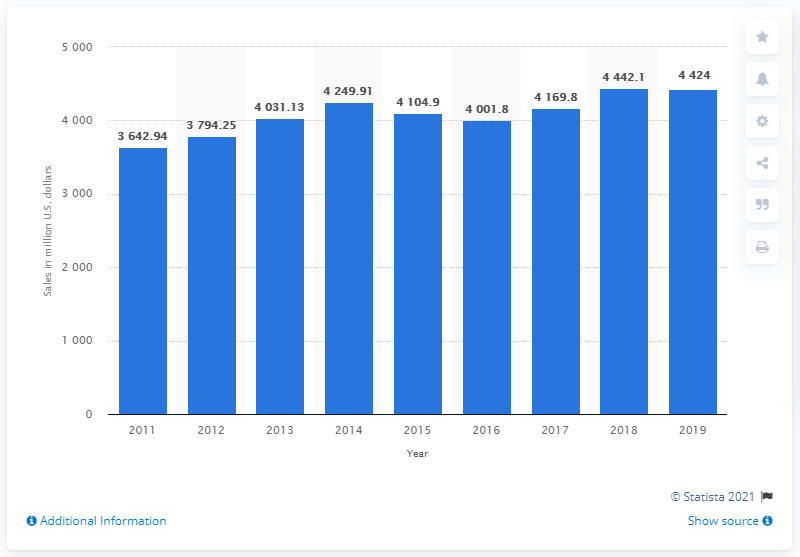Specify some key components in this picture. Tiffany & Co.'s net sales decreased by 18.1% from 2018 to 2019. In 2019, Tiffany & Co. had the second highest net sales among all years. In 2019, the net sales of Tiffany and Co. were 4,424. 